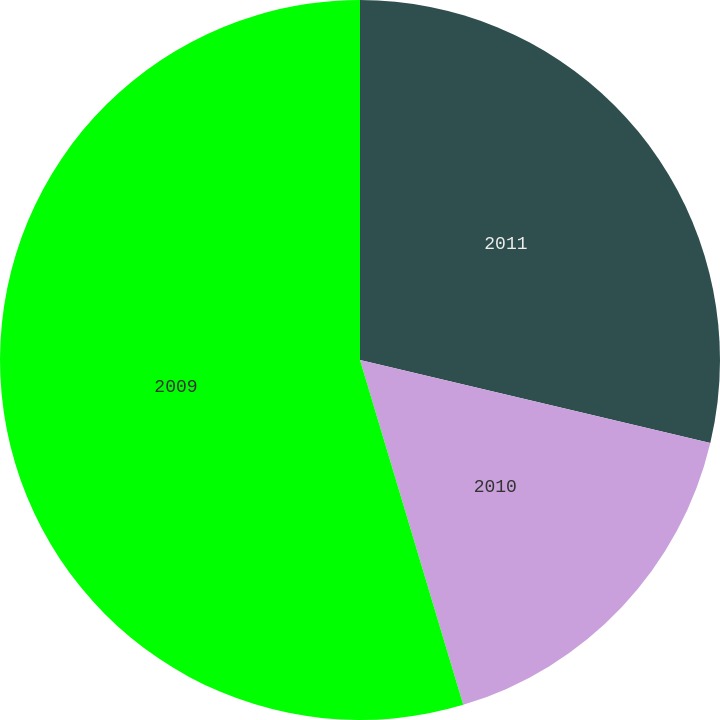<chart> <loc_0><loc_0><loc_500><loc_500><pie_chart><fcel>2011<fcel>2010<fcel>2009<nl><fcel>28.7%<fcel>16.67%<fcel>54.63%<nl></chart> 